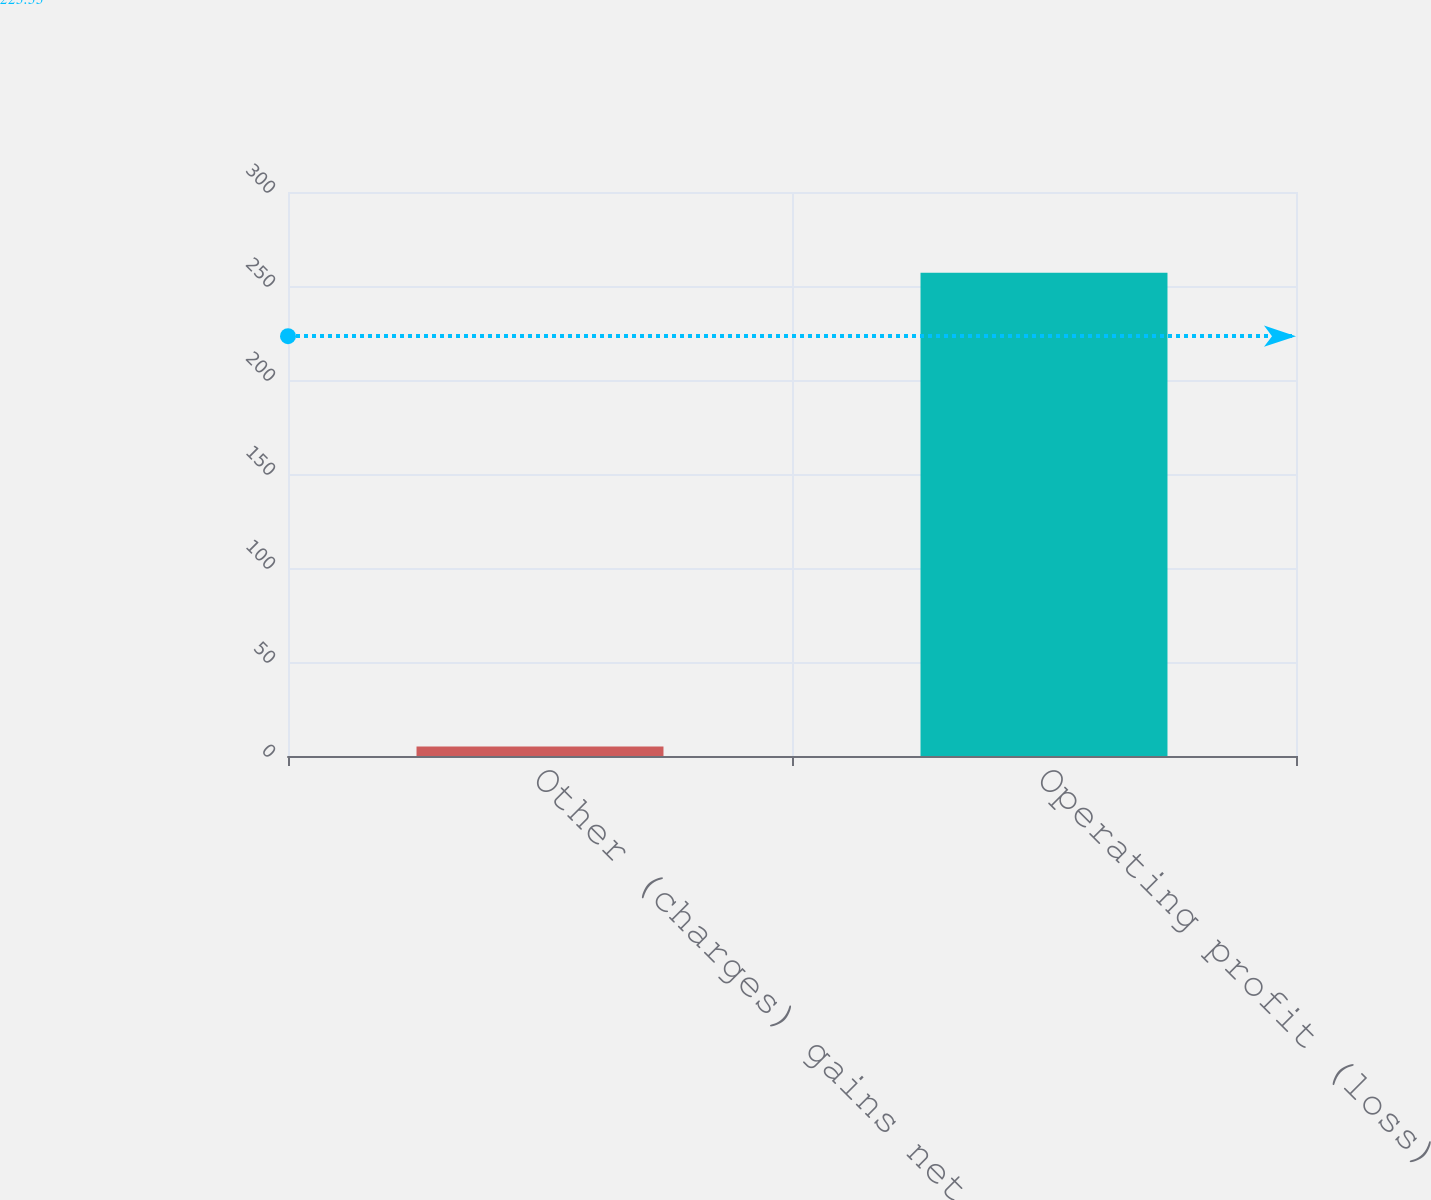Convert chart. <chart><loc_0><loc_0><loc_500><loc_500><bar_chart><fcel>Other (charges) gains net<fcel>Operating profit (loss)<nl><fcel>5<fcel>257<nl></chart> 